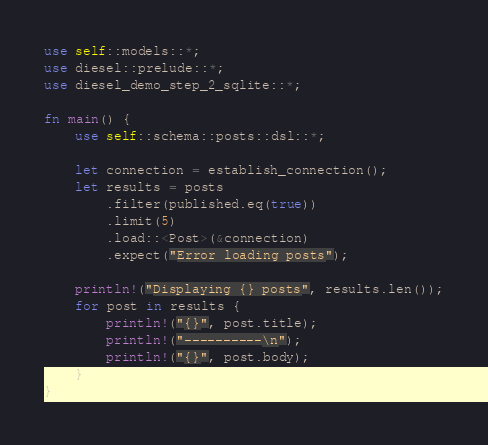<code> <loc_0><loc_0><loc_500><loc_500><_Rust_>
use self::models::*;
use diesel::prelude::*;
use diesel_demo_step_2_sqlite::*;

fn main() {
    use self::schema::posts::dsl::*;

    let connection = establish_connection();
    let results = posts
        .filter(published.eq(true))
        .limit(5)
        .load::<Post>(&connection)
        .expect("Error loading posts");

    println!("Displaying {} posts", results.len());
    for post in results {
        println!("{}", post.title);
        println!("----------\n");
        println!("{}", post.body);
    }
}
</code> 